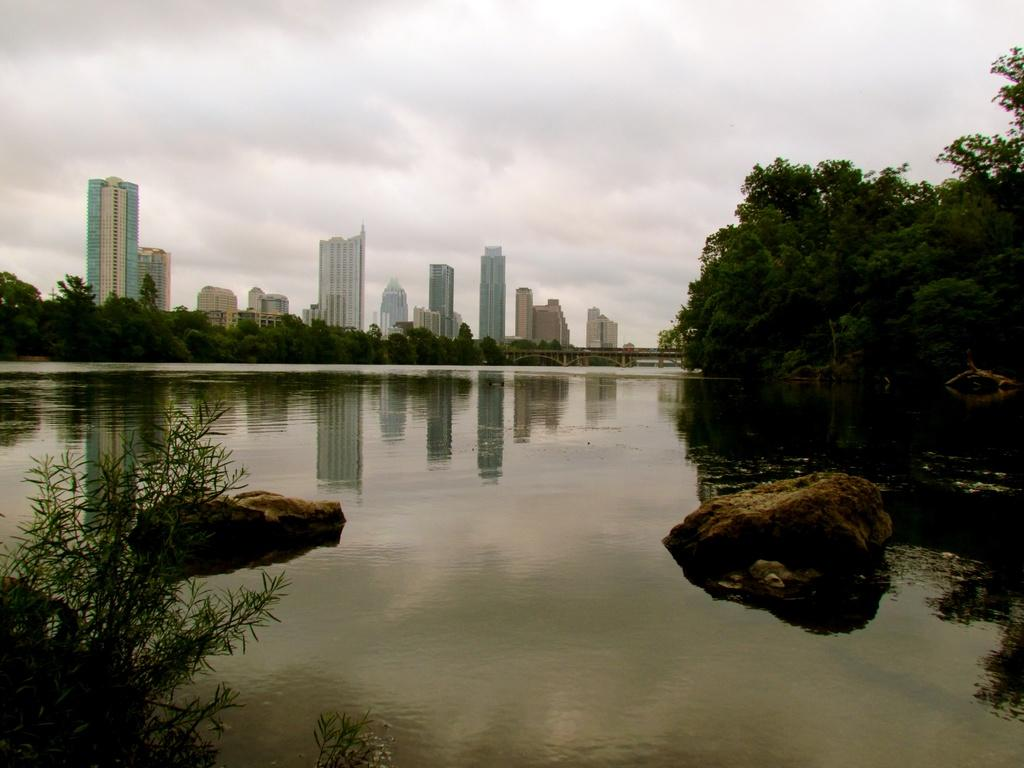What is in the water in the image? There are rocks in the water in the image. What can be seen in the background of the image? There are trees, buildings, a bridge, and the sky visible in the background of the image. Where is the plant located in the image? The plant is in the bottom left corner of the image. What type of cake is being used to fix the wrench in the image? There is no cake or wrench present in the image. What color is the powder that is covering the plant in the image? There is no powder present in the image; only the plant is visible in the bottom left corner. 